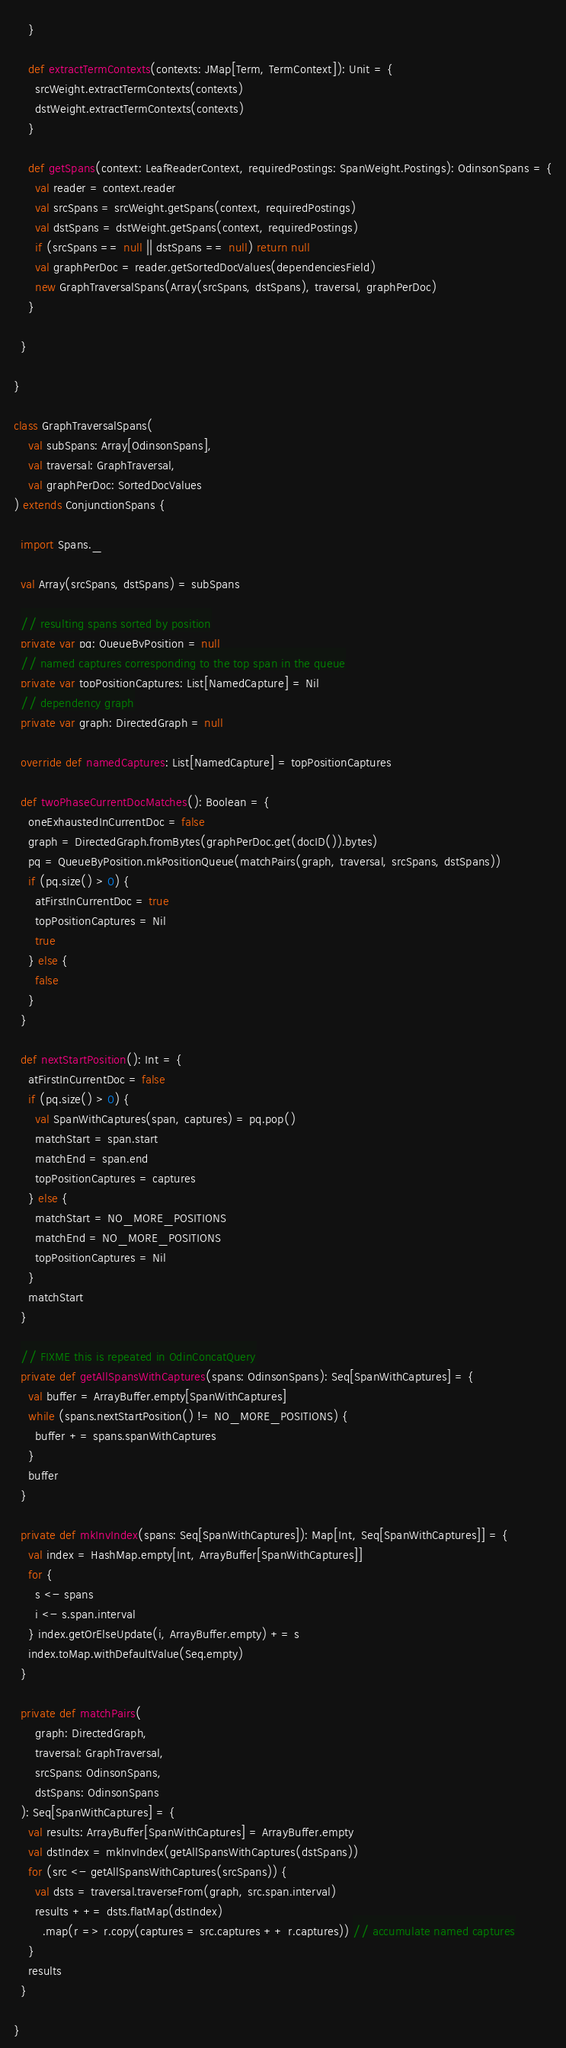Convert code to text. <code><loc_0><loc_0><loc_500><loc_500><_Scala_>    }

    def extractTermContexts(contexts: JMap[Term, TermContext]): Unit = {
      srcWeight.extractTermContexts(contexts)
      dstWeight.extractTermContexts(contexts)
    }

    def getSpans(context: LeafReaderContext, requiredPostings: SpanWeight.Postings): OdinsonSpans = {
      val reader = context.reader
      val srcSpans = srcWeight.getSpans(context, requiredPostings)
      val dstSpans = dstWeight.getSpans(context, requiredPostings)
      if (srcSpans == null || dstSpans == null) return null
      val graphPerDoc = reader.getSortedDocValues(dependenciesField)
      new GraphTraversalSpans(Array(srcSpans, dstSpans), traversal, graphPerDoc)
    }

  }

}

class GraphTraversalSpans(
    val subSpans: Array[OdinsonSpans],
    val traversal: GraphTraversal,
    val graphPerDoc: SortedDocValues
) extends ConjunctionSpans {

  import Spans._

  val Array(srcSpans, dstSpans) = subSpans

  // resulting spans sorted by position
  private var pq: QueueByPosition = null
  // named captures corresponding to the top span in the queue
  private var topPositionCaptures: List[NamedCapture] = Nil
  // dependency graph
  private var graph: DirectedGraph = null

  override def namedCaptures: List[NamedCapture] = topPositionCaptures

  def twoPhaseCurrentDocMatches(): Boolean = {
    oneExhaustedInCurrentDoc = false
    graph = DirectedGraph.fromBytes(graphPerDoc.get(docID()).bytes)
    pq = QueueByPosition.mkPositionQueue(matchPairs(graph, traversal, srcSpans, dstSpans))
    if (pq.size() > 0) {
      atFirstInCurrentDoc = true
      topPositionCaptures = Nil
      true
    } else {
      false
    }
  }

  def nextStartPosition(): Int = {
    atFirstInCurrentDoc = false
    if (pq.size() > 0) {
      val SpanWithCaptures(span, captures) = pq.pop()
      matchStart = span.start
      matchEnd = span.end
      topPositionCaptures = captures
    } else {
      matchStart = NO_MORE_POSITIONS
      matchEnd = NO_MORE_POSITIONS
      topPositionCaptures = Nil
    }
    matchStart
  }

  // FIXME this is repeated in OdinConcatQuery
  private def getAllSpansWithCaptures(spans: OdinsonSpans): Seq[SpanWithCaptures] = {
    val buffer = ArrayBuffer.empty[SpanWithCaptures]
    while (spans.nextStartPosition() != NO_MORE_POSITIONS) {
      buffer += spans.spanWithCaptures
    }
    buffer
  }

  private def mkInvIndex(spans: Seq[SpanWithCaptures]): Map[Int, Seq[SpanWithCaptures]] = {
    val index = HashMap.empty[Int, ArrayBuffer[SpanWithCaptures]]
    for {
      s <- spans
      i <- s.span.interval
    } index.getOrElseUpdate(i, ArrayBuffer.empty) += s
    index.toMap.withDefaultValue(Seq.empty)
  }

  private def matchPairs(
      graph: DirectedGraph,
      traversal: GraphTraversal,
      srcSpans: OdinsonSpans,
      dstSpans: OdinsonSpans
  ): Seq[SpanWithCaptures] = {
    val results: ArrayBuffer[SpanWithCaptures] = ArrayBuffer.empty
    val dstIndex = mkInvIndex(getAllSpansWithCaptures(dstSpans))
    for (src <- getAllSpansWithCaptures(srcSpans)) {
      val dsts = traversal.traverseFrom(graph, src.span.interval)
      results ++= dsts.flatMap(dstIndex)
        .map(r => r.copy(captures = src.captures ++ r.captures)) // accumulate named captures
    }
    results
  }

}
</code> 